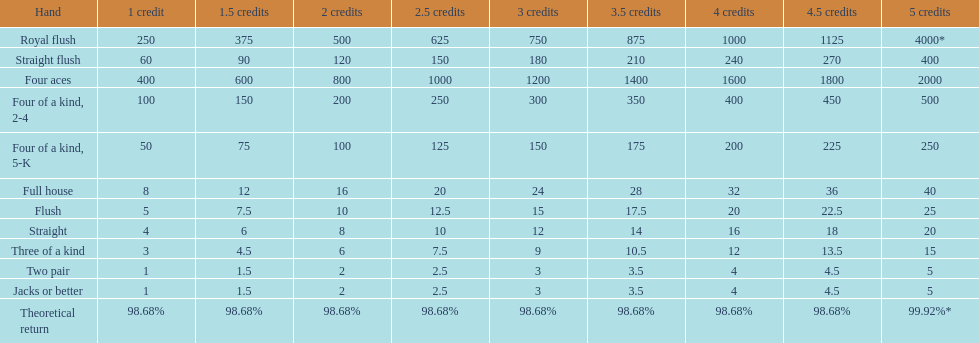At most, what could a person earn for having a full house? 40. 